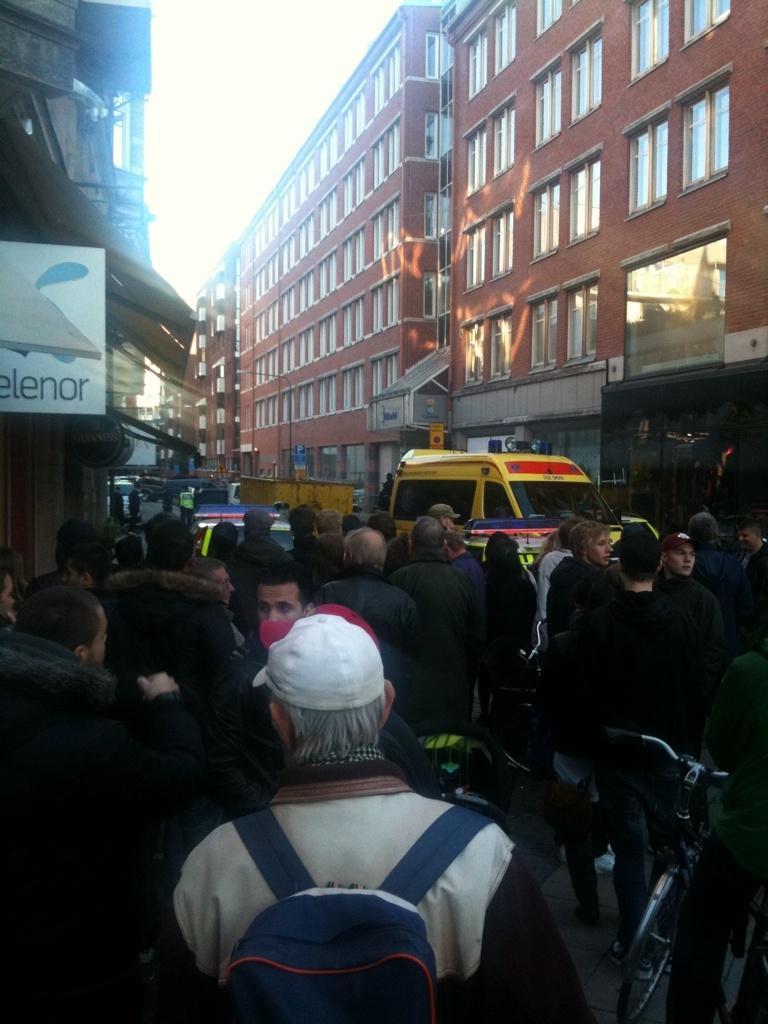In one or two sentences, can you explain what this image depicts? This picture is clicked outside. In the foreground we can see the group of people. On the left corner there is a board attached to the building on which we can see the text is printed. In the center we can see the vehicles. In the background there is a sky and the buildings. 